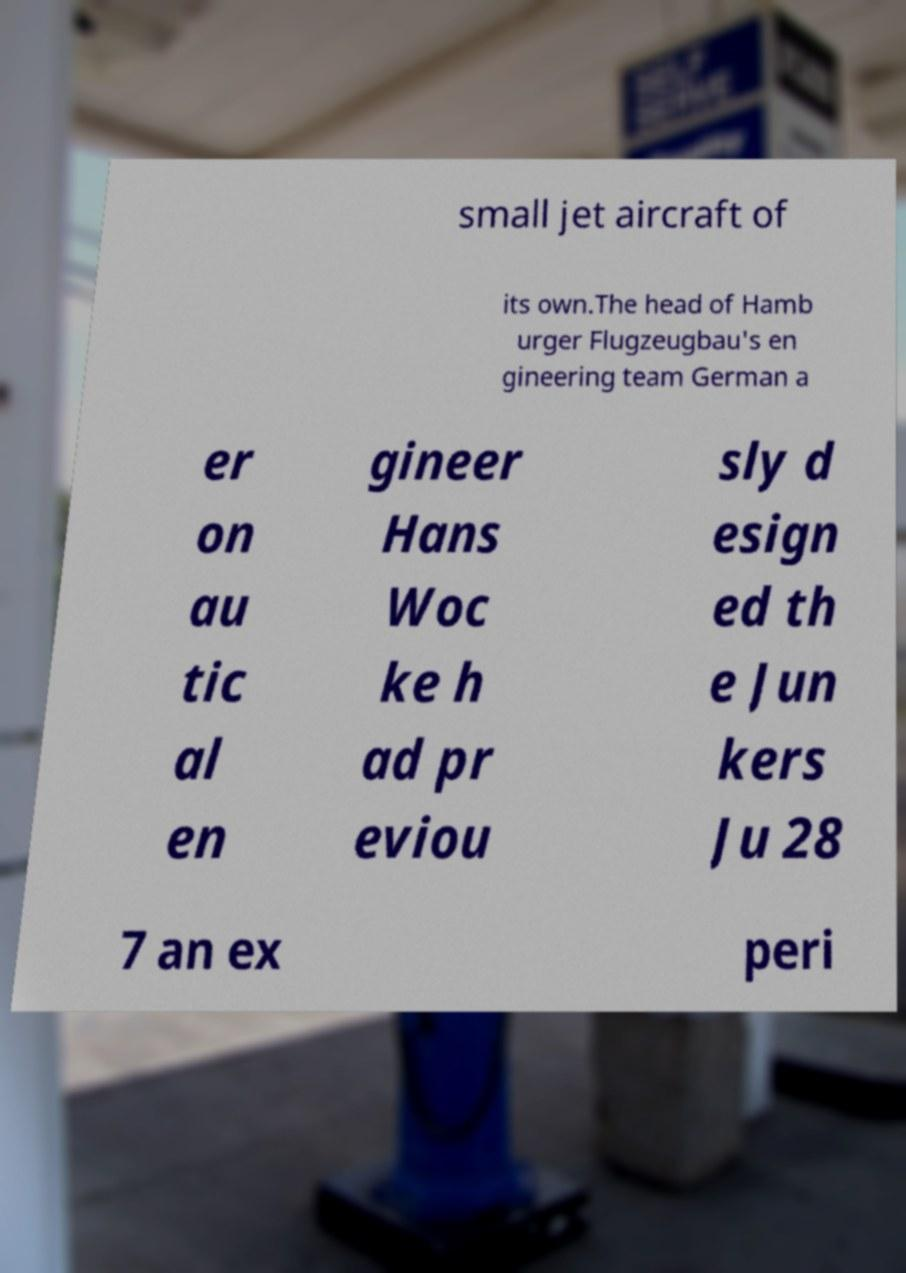Can you read and provide the text displayed in the image?This photo seems to have some interesting text. Can you extract and type it out for me? small jet aircraft of its own.The head of Hamb urger Flugzeugbau's en gineering team German a er on au tic al en gineer Hans Woc ke h ad pr eviou sly d esign ed th e Jun kers Ju 28 7 an ex peri 